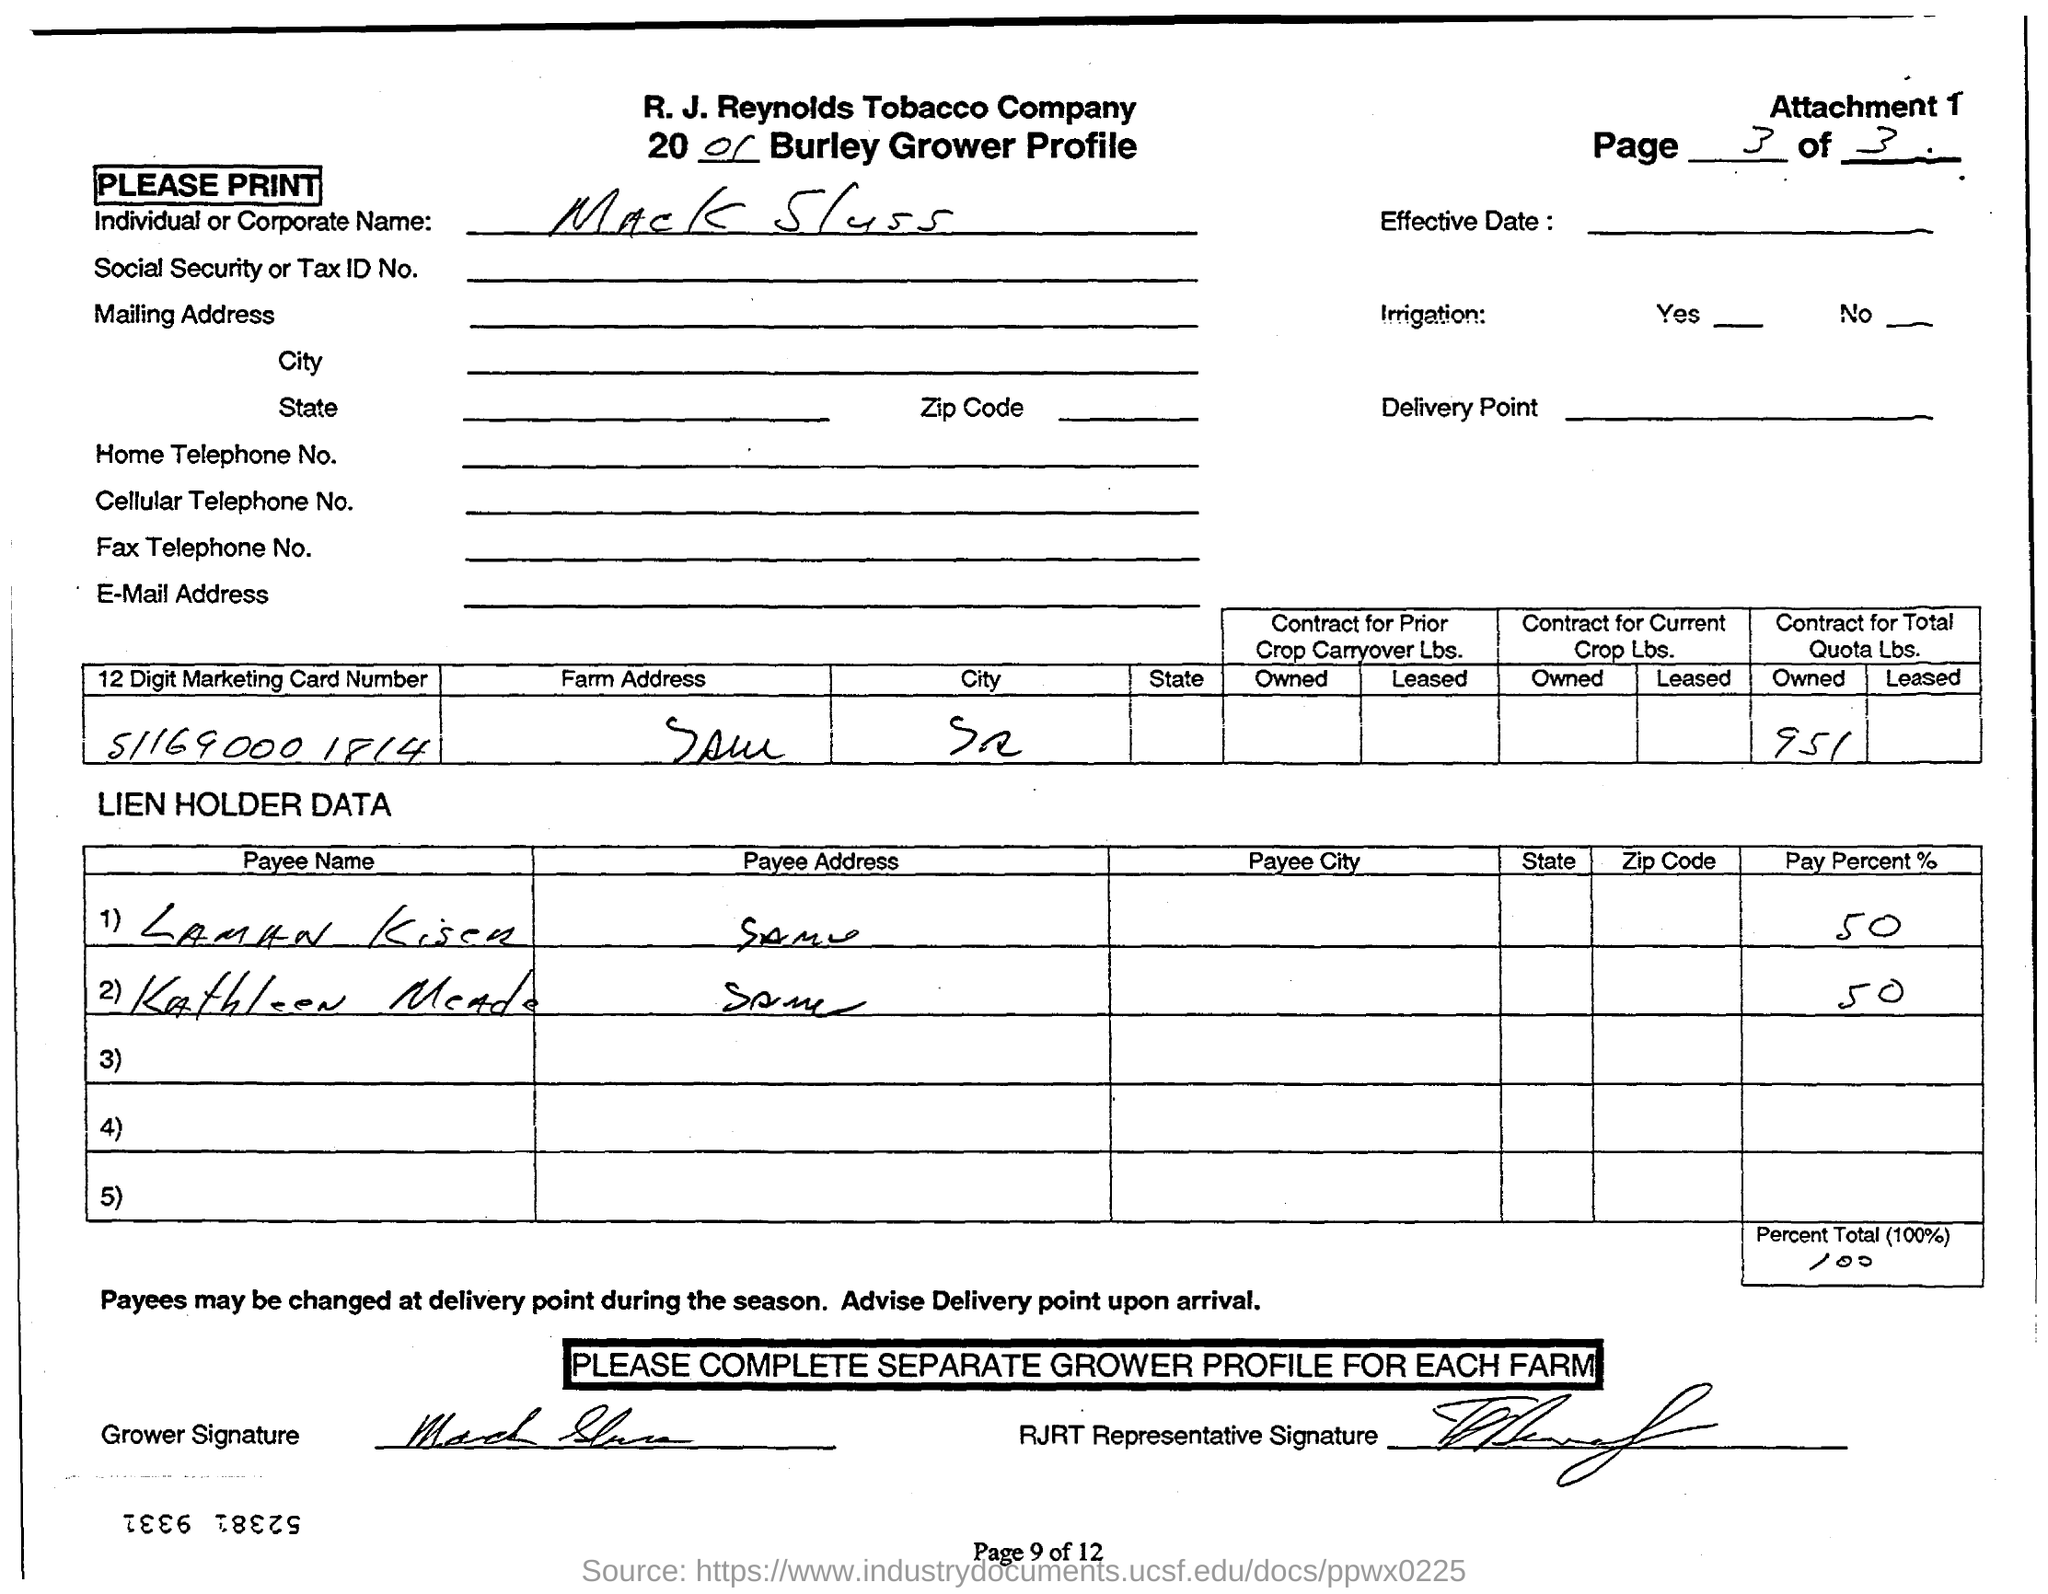What is the 12 digit marketing Card number?
Keep it short and to the point. 51169000 1814. Who is the individual  or corporate name?
Give a very brief answer. Mack Sluss. 